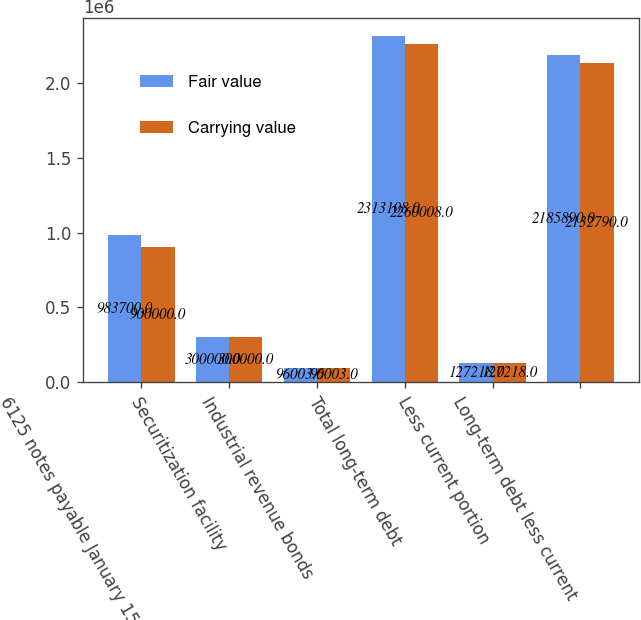Convert chart to OTSL. <chart><loc_0><loc_0><loc_500><loc_500><stacked_bar_chart><ecel><fcel>6125 notes payable January 15<fcel>Securitization facility<fcel>Industrial revenue bonds<fcel>Total long-term debt<fcel>Less current portion<fcel>Long-term debt less current<nl><fcel>Fair value<fcel>983700<fcel>300000<fcel>96003<fcel>2.31311e+06<fcel>127218<fcel>2.18589e+06<nl><fcel>Carrying value<fcel>900000<fcel>300000<fcel>96003<fcel>2.26001e+06<fcel>127218<fcel>2.13279e+06<nl></chart> 